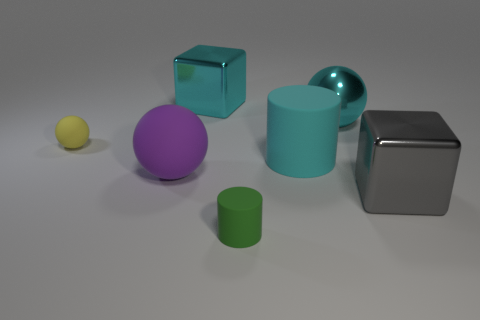Add 2 tiny red matte spheres. How many objects exist? 9 Subtract all balls. How many objects are left? 4 Add 1 cyan metal objects. How many cyan metal objects exist? 3 Subtract 0 blue cylinders. How many objects are left? 7 Subtract all large brown shiny cylinders. Subtract all yellow matte objects. How many objects are left? 6 Add 5 large purple matte objects. How many large purple matte objects are left? 6 